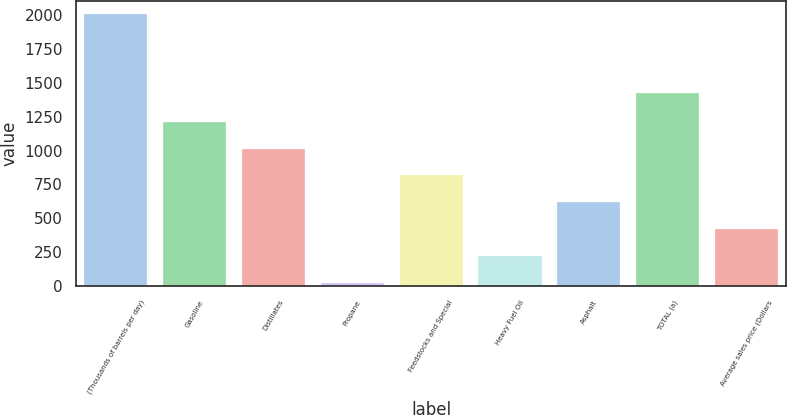<chart> <loc_0><loc_0><loc_500><loc_500><bar_chart><fcel>(Thousands of barrels per day)<fcel>Gasoline<fcel>Distillates<fcel>Propane<fcel>Feedstocks and Special<fcel>Heavy Fuel Oil<fcel>Asphalt<fcel>TOTAL (a)<fcel>Average sales price (Dollars<nl><fcel>2006<fcel>1212.8<fcel>1014.5<fcel>23<fcel>816.2<fcel>221.3<fcel>617.9<fcel>1425<fcel>419.6<nl></chart> 